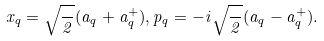<formula> <loc_0><loc_0><loc_500><loc_500>x _ { q } = \sqrt { \frac { } { 2 } } ( a _ { q } + a _ { q } ^ { + } ) , p _ { q } = - i \sqrt { \frac { } { 2 } } ( a _ { q } - a _ { q } ^ { + } ) .</formula> 